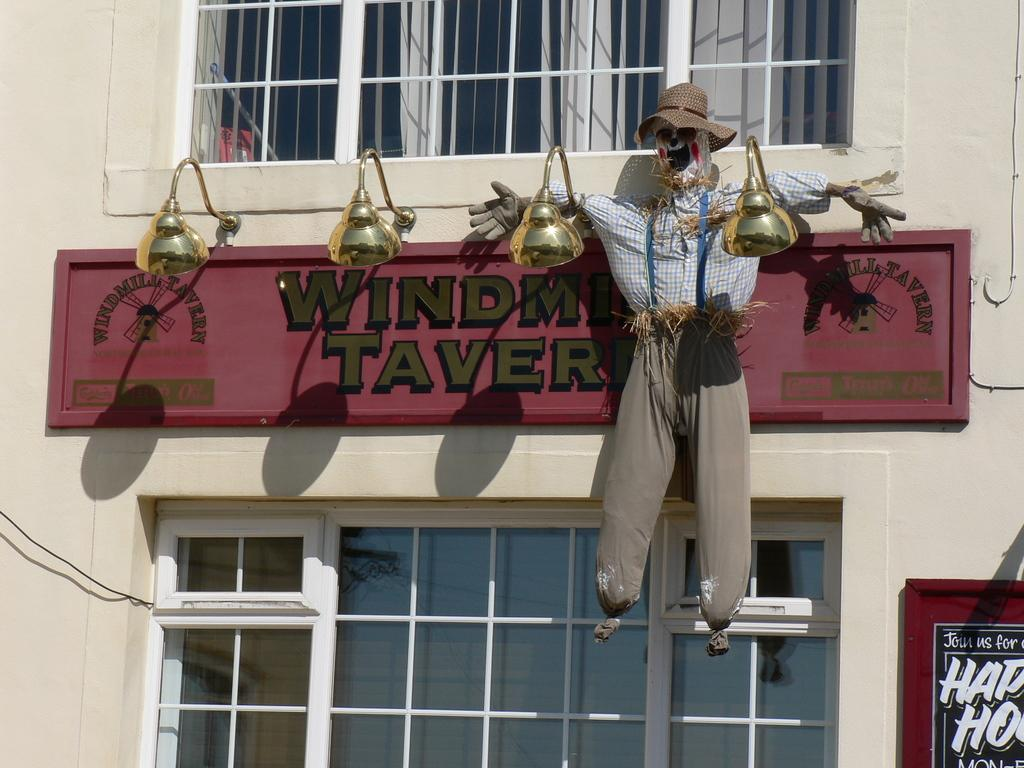What is the main subject of the image? The main subject of the image is a building's wall. What can be seen attached to the wall? There are two boards on the wall. What else can be seen on the wall? There are lights and windows visible on the wall. What is present in front of the wall? There is a scarecrow in the image. What is written on the boards? There is writing on the boards. What degree of hope can be seen in the steam coming from the scarecrow's mouth in the image? There is no steam coming from the scarecrow's mouth in the image, and therefore no degree of hope can be determined. 